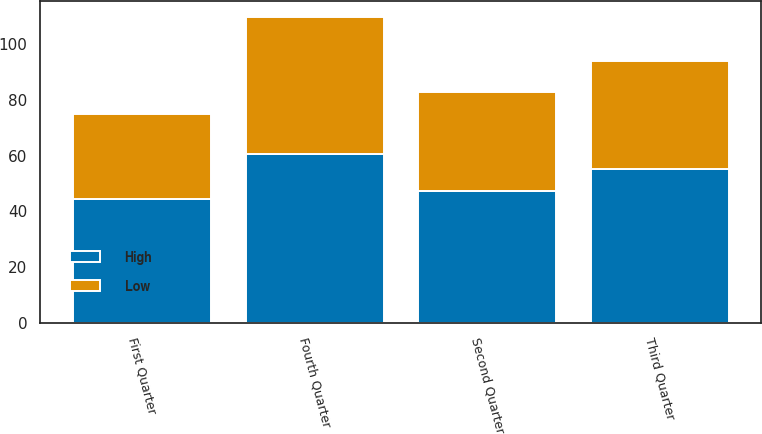Convert chart to OTSL. <chart><loc_0><loc_0><loc_500><loc_500><stacked_bar_chart><ecel><fcel>First Quarter<fcel>Second Quarter<fcel>Third Quarter<fcel>Fourth Quarter<nl><fcel>High<fcel>44.36<fcel>47.41<fcel>55.25<fcel>60.64<nl><fcel>Low<fcel>30.67<fcel>35.36<fcel>38.55<fcel>49.14<nl></chart> 